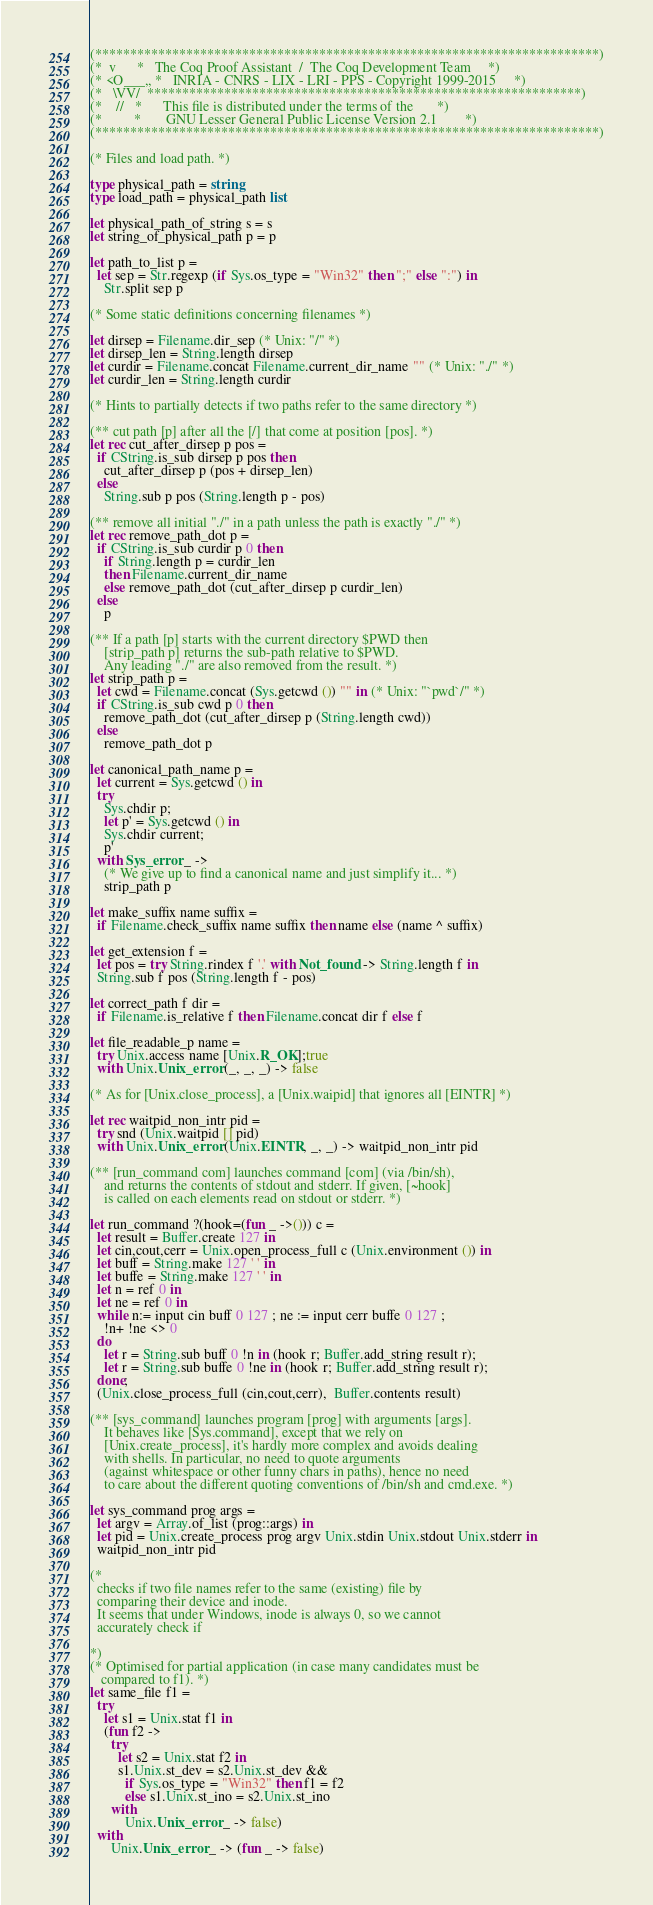<code> <loc_0><loc_0><loc_500><loc_500><_OCaml_>(************************************************************************)
(*  v      *   The Coq Proof Assistant  /  The Coq Development Team     *)
(* <O___,, *   INRIA - CNRS - LIX - LRI - PPS - Copyright 1999-2015     *)
(*   \VV/  **************************************************************)
(*    //   *      This file is distributed under the terms of the       *)
(*         *       GNU Lesser General Public License Version 2.1        *)
(************************************************************************)

(* Files and load path. *)

type physical_path = string
type load_path = physical_path list

let physical_path_of_string s = s
let string_of_physical_path p = p

let path_to_list p =
  let sep = Str.regexp (if Sys.os_type = "Win32" then ";" else ":") in
    Str.split sep p

(* Some static definitions concerning filenames *)

let dirsep = Filename.dir_sep (* Unix: "/" *)
let dirsep_len = String.length dirsep
let curdir = Filename.concat Filename.current_dir_name "" (* Unix: "./" *)
let curdir_len = String.length curdir

(* Hints to partially detects if two paths refer to the same directory *)

(** cut path [p] after all the [/] that come at position [pos]. *)
let rec cut_after_dirsep p pos =
  if CString.is_sub dirsep p pos then
    cut_after_dirsep p (pos + dirsep_len)
  else
    String.sub p pos (String.length p - pos)

(** remove all initial "./" in a path unless the path is exactly "./" *)
let rec remove_path_dot p =
  if CString.is_sub curdir p 0 then
    if String.length p = curdir_len
    then Filename.current_dir_name
    else remove_path_dot (cut_after_dirsep p curdir_len)
  else
    p

(** If a path [p] starts with the current directory $PWD then
    [strip_path p] returns the sub-path relative to $PWD.
    Any leading "./" are also removed from the result. *)
let strip_path p =
  let cwd = Filename.concat (Sys.getcwd ()) "" in (* Unix: "`pwd`/" *)
  if CString.is_sub cwd p 0 then
    remove_path_dot (cut_after_dirsep p (String.length cwd))
  else
    remove_path_dot p

let canonical_path_name p =
  let current = Sys.getcwd () in
  try
    Sys.chdir p;
    let p' = Sys.getcwd () in
    Sys.chdir current;
    p'
  with Sys_error _ ->
    (* We give up to find a canonical name and just simplify it... *)
    strip_path p

let make_suffix name suffix =
  if Filename.check_suffix name suffix then name else (name ^ suffix)

let get_extension f =
  let pos = try String.rindex f '.' with Not_found -> String.length f in
  String.sub f pos (String.length f - pos)

let correct_path f dir =
  if Filename.is_relative f then Filename.concat dir f else f

let file_readable_p name =
  try Unix.access name [Unix.R_OK];true
  with Unix.Unix_error (_, _, _) -> false

(* As for [Unix.close_process], a [Unix.waipid] that ignores all [EINTR] *)

let rec waitpid_non_intr pid =
  try snd (Unix.waitpid [] pid)
  with Unix.Unix_error (Unix.EINTR, _, _) -> waitpid_non_intr pid

(** [run_command com] launches command [com] (via /bin/sh),
    and returns the contents of stdout and stderr. If given, [~hook]
    is called on each elements read on stdout or stderr. *)

let run_command ?(hook=(fun _ ->())) c =
  let result = Buffer.create 127 in
  let cin,cout,cerr = Unix.open_process_full c (Unix.environment ()) in
  let buff = String.make 127 ' ' in
  let buffe = String.make 127 ' ' in
  let n = ref 0 in
  let ne = ref 0 in
  while n:= input cin buff 0 127 ; ne := input cerr buffe 0 127 ;
    !n+ !ne <> 0
  do
    let r = String.sub buff 0 !n in (hook r; Buffer.add_string result r);
    let r = String.sub buffe 0 !ne in (hook r; Buffer.add_string result r);
  done;
  (Unix.close_process_full (cin,cout,cerr),  Buffer.contents result)

(** [sys_command] launches program [prog] with arguments [args].
    It behaves like [Sys.command], except that we rely on
    [Unix.create_process], it's hardly more complex and avoids dealing
    with shells. In particular, no need to quote arguments
    (against whitespace or other funny chars in paths), hence no need
    to care about the different quoting conventions of /bin/sh and cmd.exe. *)

let sys_command prog args =
  let argv = Array.of_list (prog::args) in
  let pid = Unix.create_process prog argv Unix.stdin Unix.stdout Unix.stderr in
  waitpid_non_intr pid

(*
  checks if two file names refer to the same (existing) file by
  comparing their device and inode.
  It seems that under Windows, inode is always 0, so we cannot
  accurately check if

*)
(* Optimised for partial application (in case many candidates must be
   compared to f1). *)
let same_file f1 =
  try
    let s1 = Unix.stat f1 in
    (fun f2 ->
      try
        let s2 = Unix.stat f2 in
        s1.Unix.st_dev = s2.Unix.st_dev &&
          if Sys.os_type = "Win32" then f1 = f2
          else s1.Unix.st_ino = s2.Unix.st_ino
      with
          Unix.Unix_error _ -> false)
  with
      Unix.Unix_error _ -> (fun _ -> false)
</code> 